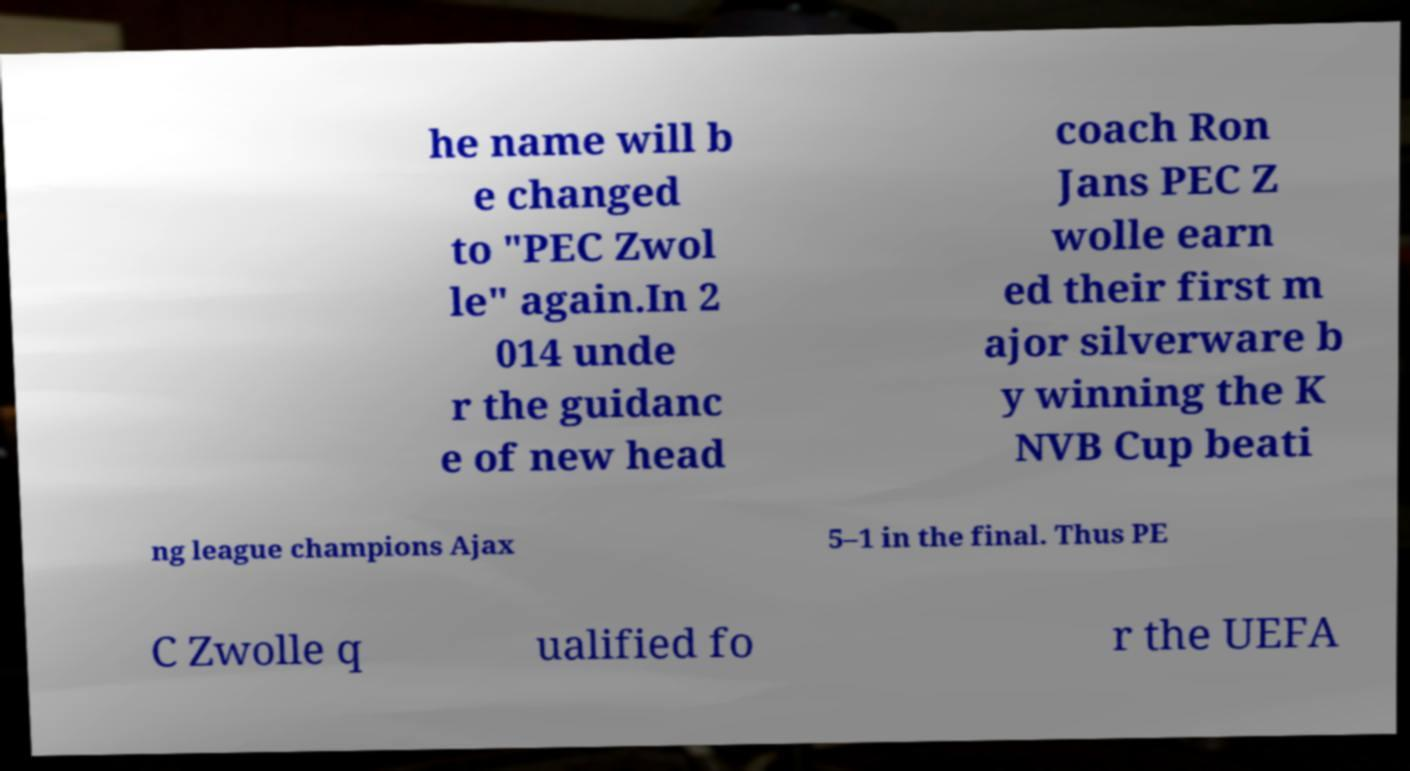Can you read and provide the text displayed in the image?This photo seems to have some interesting text. Can you extract and type it out for me? he name will b e changed to "PEC Zwol le" again.In 2 014 unde r the guidanc e of new head coach Ron Jans PEC Z wolle earn ed their first m ajor silverware b y winning the K NVB Cup beati ng league champions Ajax 5–1 in the final. Thus PE C Zwolle q ualified fo r the UEFA 